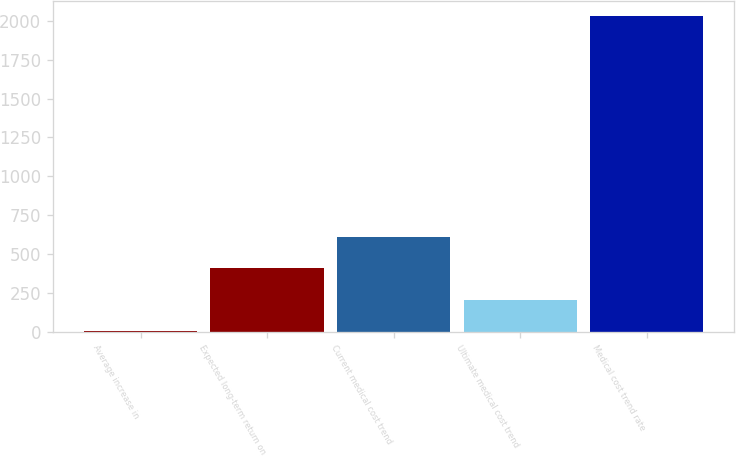<chart> <loc_0><loc_0><loc_500><loc_500><bar_chart><fcel>Average increase in<fcel>Expected long-term return on<fcel>Current medical cost trend<fcel>Ultimate medical cost trend<fcel>Medical cost trend rate<nl><fcel>3.5<fcel>408.4<fcel>610.85<fcel>205.95<fcel>2028<nl></chart> 